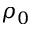<formula> <loc_0><loc_0><loc_500><loc_500>\rho _ { 0 }</formula> 